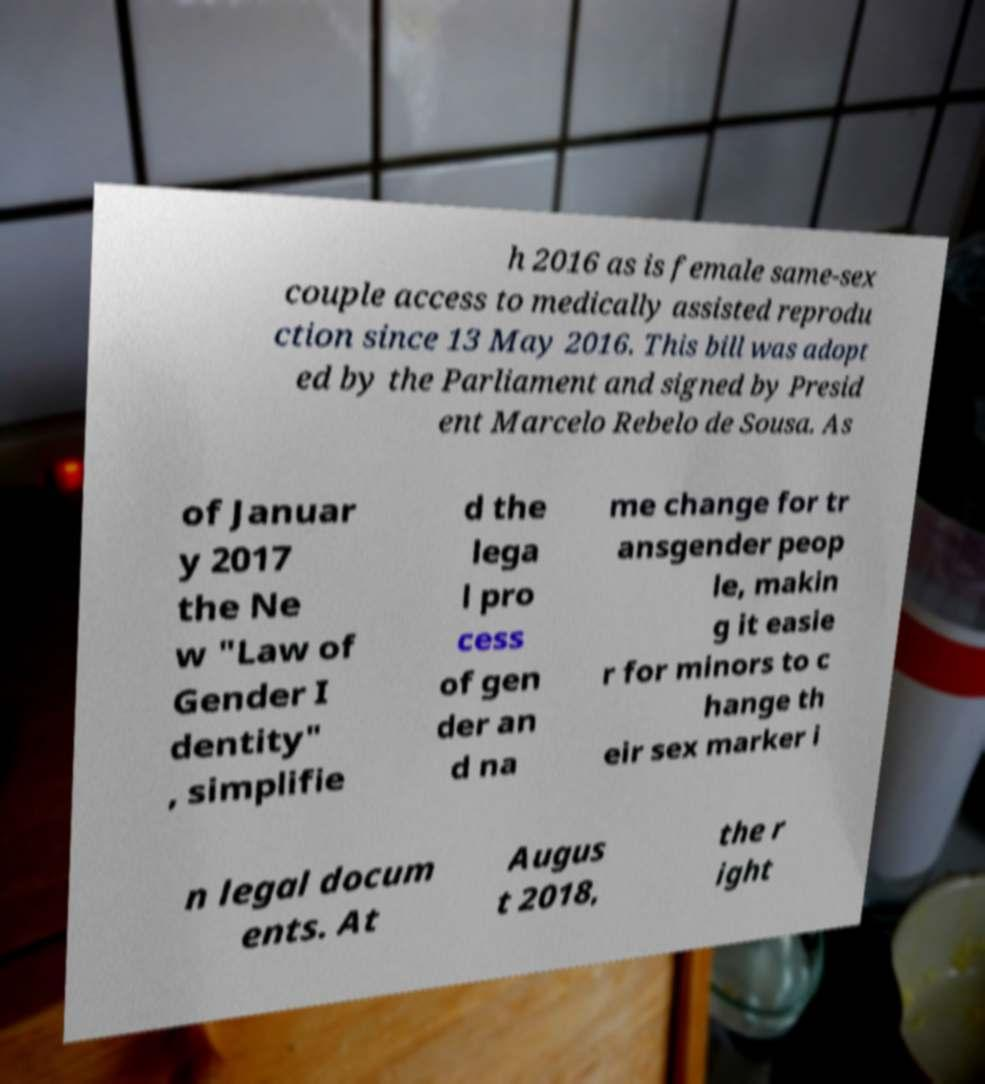Can you read and provide the text displayed in the image?This photo seems to have some interesting text. Can you extract and type it out for me? h 2016 as is female same-sex couple access to medically assisted reprodu ction since 13 May 2016. This bill was adopt ed by the Parliament and signed by Presid ent Marcelo Rebelo de Sousa. As of Januar y 2017 the Ne w "Law of Gender I dentity" , simplifie d the lega l pro cess of gen der an d na me change for tr ansgender peop le, makin g it easie r for minors to c hange th eir sex marker i n legal docum ents. At Augus t 2018, the r ight 